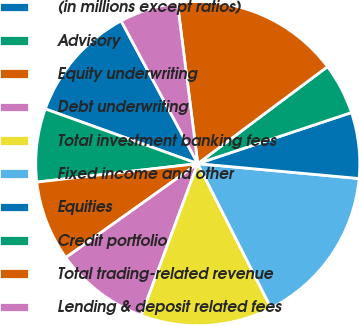<chart> <loc_0><loc_0><loc_500><loc_500><pie_chart><fcel>(in millions except ratios)<fcel>Advisory<fcel>Equity underwriting<fcel>Debt underwriting<fcel>Total investment banking fees<fcel>Fixed income and other<fcel>Equities<fcel>Credit portfolio<fcel>Total trading-related revenue<fcel>Lending & deposit related fees<nl><fcel>11.68%<fcel>7.3%<fcel>8.03%<fcel>9.49%<fcel>13.14%<fcel>16.06%<fcel>6.57%<fcel>5.11%<fcel>16.79%<fcel>5.84%<nl></chart> 